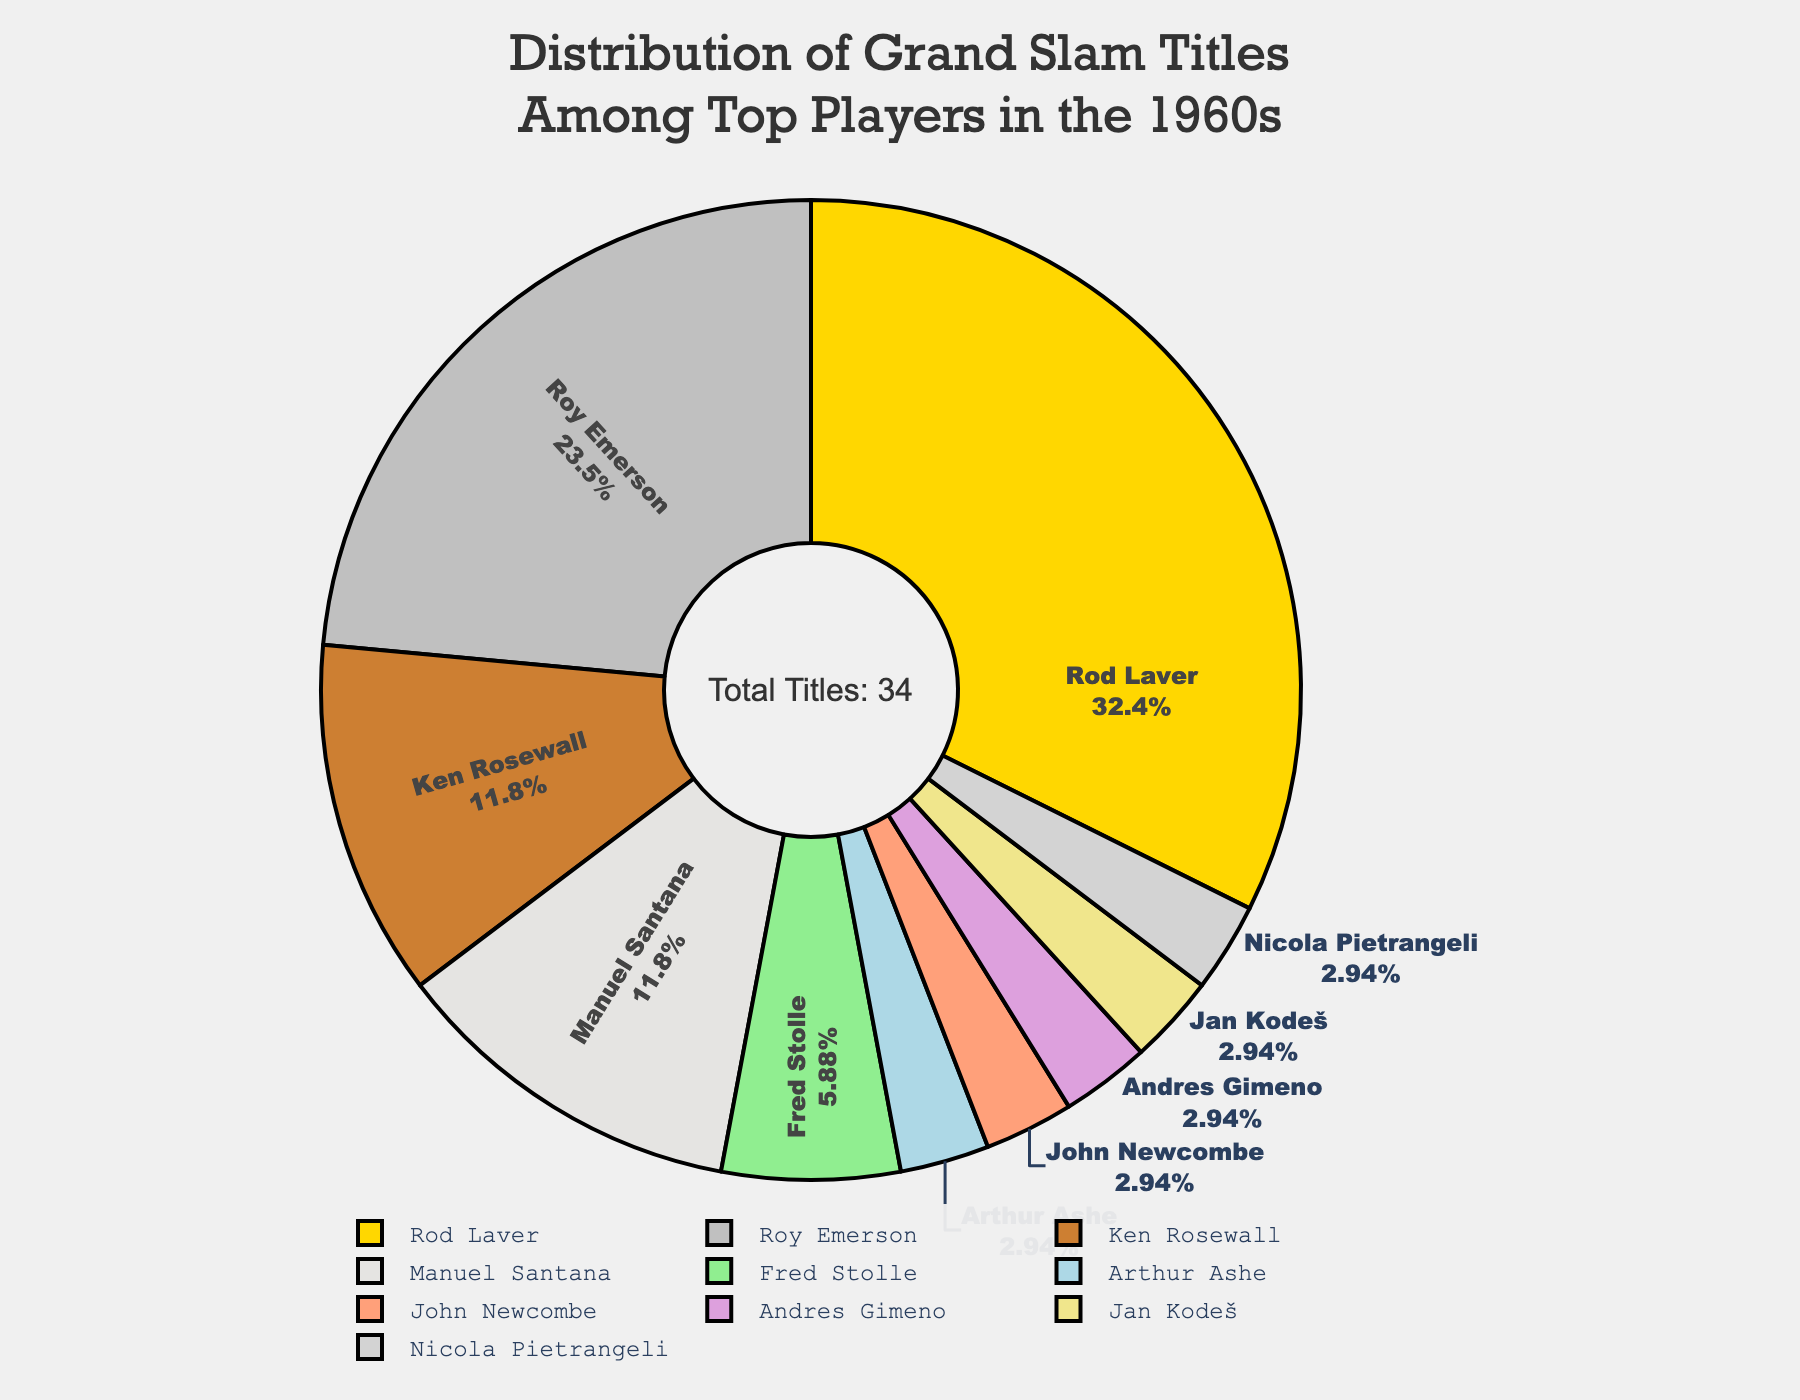Who won the most Grand Slam titles in the 1960s? The pie chart title mentions the distribution of Grand Slam titles among top players in the 1960s, and by observing the slices of the pie, we see that Rod Laver's slice is the largest. His name and the number of titles (11) are clearly labeled.
Answer: Rod Laver How many more Grand Slam titles did Rod Laver win compared to Roy Emerson? Compare the number of titles won by Rod Laver and Roy Emerson. Rod Laver won 11 titles while Roy Emerson won 8. Calculate the difference: 11 - 8 = 3.
Answer: 3 What percentage of the total Grand Slam titles in the 1960s were won by Ken Rosewall? Ken Rosewall won 4 Grand Slam titles. The total number of titles displayed in the chart is 34. The percentage is calculated as (4/34)*100 ≈ 11.76%.
Answer: Approx. 11.76% How many players won only one Grand Slam title in the 1960s? Observe the pie chart for players with only one title. The listed players are Arthur Ashe, John Newcombe, Andres Gimeno, Jan Kodeš, and Nicola Pietrangeli. Counting these, we find there are 5 such players.
Answer: 5 Which two players have an equal number of Grand Slam titles, and how many do they have? From the pie chart labels, Ken Rosewall and Manuel Santana both have slices labeled with 4 Grand Slam titles each.
Answer: Ken Rosewall and Manuel Santana, 4 What is the combined total of Grand Slam titles won by players other than Rod Laver and Roy Emerson? The total number of Grand Slam titles from the pie chart is 34. Rod Laver won 11, and Roy Emerson won 8. Subtract their combined titles from the total to get the rest: 34 - 11 - 8 = 15.
Answer: 15 What is the smallest slice on the pie chart, and who does it represent? Look at the pie chart to identify the smallest slice. Since multiple slices (Arthur Ashe, John Newcombe, Andres Gimeno, Jan Kodeš, Nicola Pietrangeli) are equally small with only 1 title each, let's pick one randomly as an example: Arthur Ashe.
Answer: Arthur Ashe Are there more players who won 1 Grand Slam title or players who won more than 4 Grand Slam titles? List players who won 1 title: Arthur Ashe, John Newcombe, Andres Gimeno, Jan Kodeš, Nicola Pietrangeli. That's 5 players. Now list players who won more than 4 titles: Rod Laver (11) and Roy Emerson (8), which is 2 players. There are more players with 1 title.
Answer: More with 1 title By what percentage do Rod Laver's Grand Slam titles exceed Ken Rosewall's? Rod Laver has 11 titles, and Ken Rosewall has 4. The percentage increase is calculated as ((11 - 4)/4)*100 = 175%.
Answer: 175% 